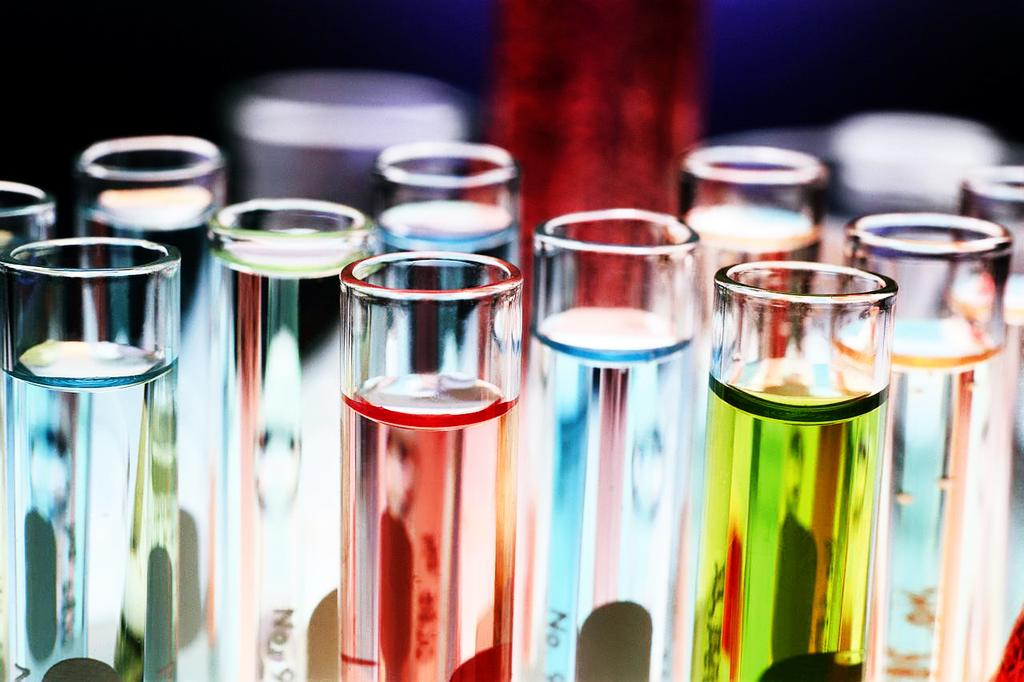<image>
Present a compact description of the photo's key features. test tubes with different colored liquids, light blue one has No written on it 